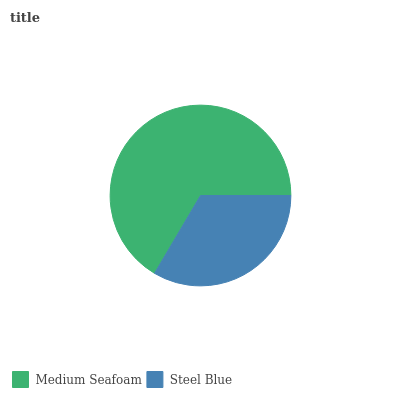Is Steel Blue the minimum?
Answer yes or no. Yes. Is Medium Seafoam the maximum?
Answer yes or no. Yes. Is Steel Blue the maximum?
Answer yes or no. No. Is Medium Seafoam greater than Steel Blue?
Answer yes or no. Yes. Is Steel Blue less than Medium Seafoam?
Answer yes or no. Yes. Is Steel Blue greater than Medium Seafoam?
Answer yes or no. No. Is Medium Seafoam less than Steel Blue?
Answer yes or no. No. Is Medium Seafoam the high median?
Answer yes or no. Yes. Is Steel Blue the low median?
Answer yes or no. Yes. Is Steel Blue the high median?
Answer yes or no. No. Is Medium Seafoam the low median?
Answer yes or no. No. 